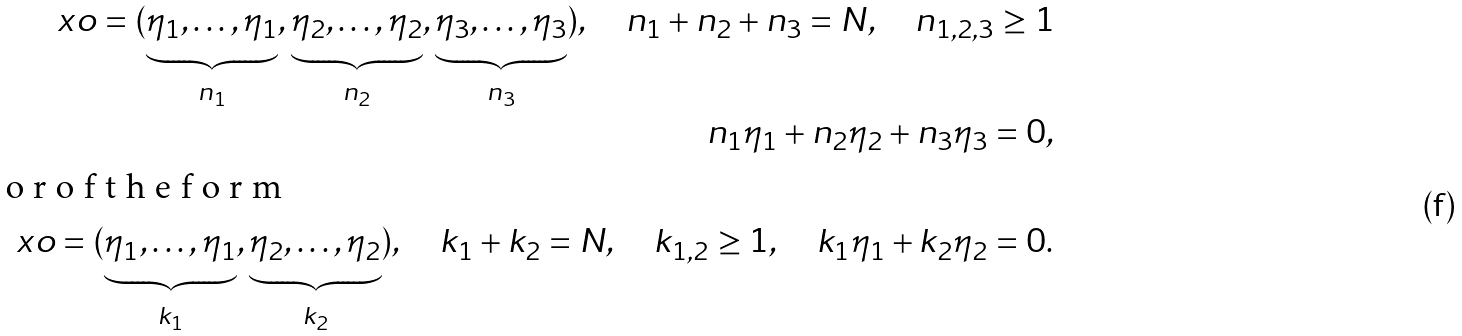<formula> <loc_0><loc_0><loc_500><loc_500>\ x o = ( \underbrace { \eta _ { 1 } , \dots , \eta _ { 1 } } _ { n _ { 1 } } , \underbrace { \eta _ { 2 } , \dots , \eta _ { 2 } } _ { n _ { 2 } } , \underbrace { \eta _ { 3 } , \dots , \eta _ { 3 } } _ { n _ { 3 } } ) , \quad n _ { 1 } + n _ { 2 } + n _ { 3 } = N , \quad n _ { 1 , 2 , 3 } \geq 1 \\ n _ { 1 } \eta _ { 1 } + n _ { 2 } \eta _ { 2 } + n _ { 3 } \eta _ { 3 } = 0 , \\ \intertext { o r o f t h e f o r m } \ x o = ( \underbrace { \eta _ { 1 } , \dots , \eta _ { 1 } } _ { k _ { 1 } } , \underbrace { \eta _ { 2 } , \dots , \eta _ { 2 } } _ { k _ { 2 } } ) , \quad k _ { 1 } + k _ { 2 } = N , \quad k _ { 1 , 2 } \geq 1 , \quad k _ { 1 } \eta _ { 1 } + k _ { 2 } \eta _ { 2 } = 0 .</formula> 